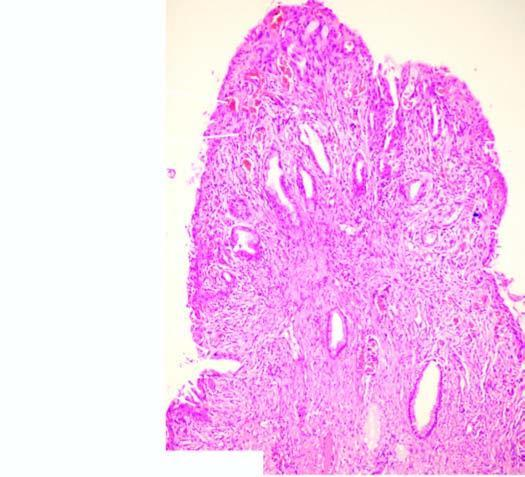s the stromal core composed of dense fibrous tissue which shows nonspecific inflammation?
Answer the question using a single word or phrase. Yes 